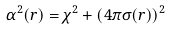Convert formula to latex. <formula><loc_0><loc_0><loc_500><loc_500>\alpha ^ { 2 } ( r ) = \chi ^ { 2 } + ( 4 \pi \sigma ( r ) ) ^ { 2 }</formula> 